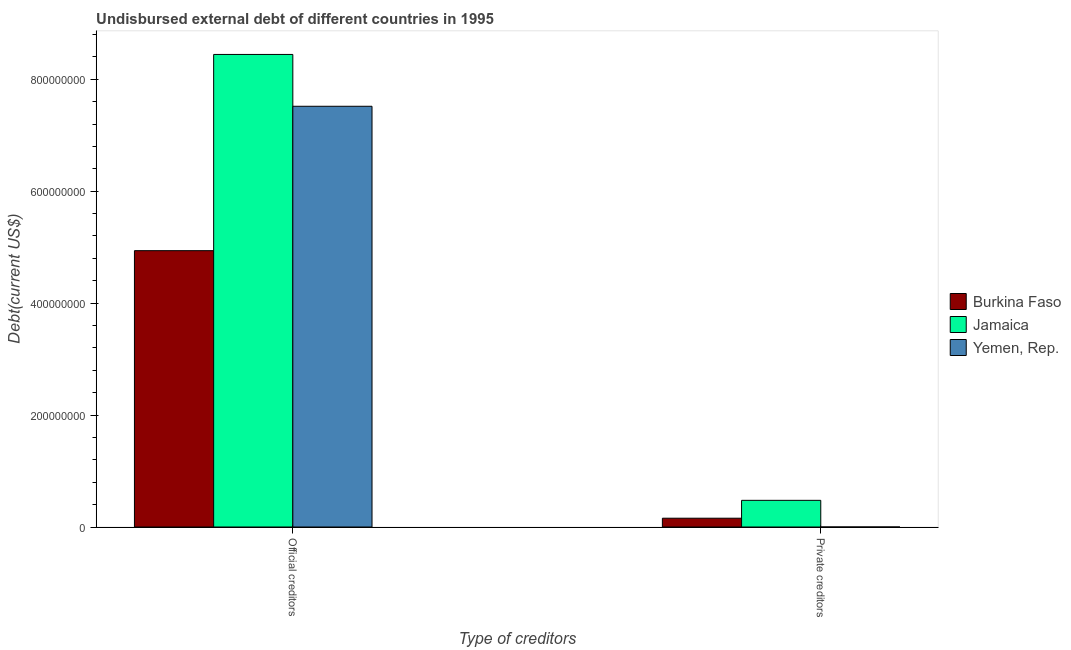Are the number of bars per tick equal to the number of legend labels?
Give a very brief answer. Yes. How many bars are there on the 2nd tick from the left?
Provide a short and direct response. 3. What is the label of the 1st group of bars from the left?
Your answer should be compact. Official creditors. What is the undisbursed external debt of private creditors in Burkina Faso?
Ensure brevity in your answer.  1.57e+07. Across all countries, what is the maximum undisbursed external debt of official creditors?
Your response must be concise. 8.44e+08. Across all countries, what is the minimum undisbursed external debt of official creditors?
Make the answer very short. 4.94e+08. In which country was the undisbursed external debt of private creditors maximum?
Your answer should be compact. Jamaica. In which country was the undisbursed external debt of private creditors minimum?
Your response must be concise. Yemen, Rep. What is the total undisbursed external debt of private creditors in the graph?
Offer a very short reply. 6.34e+07. What is the difference between the undisbursed external debt of official creditors in Yemen, Rep. and that in Burkina Faso?
Keep it short and to the point. 2.58e+08. What is the difference between the undisbursed external debt of private creditors in Jamaica and the undisbursed external debt of official creditors in Burkina Faso?
Make the answer very short. -4.46e+08. What is the average undisbursed external debt of official creditors per country?
Offer a terse response. 6.97e+08. What is the difference between the undisbursed external debt of official creditors and undisbursed external debt of private creditors in Burkina Faso?
Provide a succinct answer. 4.78e+08. What is the ratio of the undisbursed external debt of official creditors in Yemen, Rep. to that in Jamaica?
Ensure brevity in your answer.  0.89. In how many countries, is the undisbursed external debt of official creditors greater than the average undisbursed external debt of official creditors taken over all countries?
Provide a short and direct response. 2. What does the 1st bar from the left in Official creditors represents?
Ensure brevity in your answer.  Burkina Faso. What does the 2nd bar from the right in Private creditors represents?
Offer a very short reply. Jamaica. Are the values on the major ticks of Y-axis written in scientific E-notation?
Provide a succinct answer. No. Does the graph contain any zero values?
Your answer should be very brief. No. What is the title of the graph?
Your answer should be compact. Undisbursed external debt of different countries in 1995. What is the label or title of the X-axis?
Ensure brevity in your answer.  Type of creditors. What is the label or title of the Y-axis?
Your answer should be very brief. Debt(current US$). What is the Debt(current US$) of Burkina Faso in Official creditors?
Offer a very short reply. 4.94e+08. What is the Debt(current US$) of Jamaica in Official creditors?
Offer a very short reply. 8.44e+08. What is the Debt(current US$) in Yemen, Rep. in Official creditors?
Your response must be concise. 7.52e+08. What is the Debt(current US$) in Burkina Faso in Private creditors?
Keep it short and to the point. 1.57e+07. What is the Debt(current US$) of Jamaica in Private creditors?
Offer a very short reply. 4.77e+07. Across all Type of creditors, what is the maximum Debt(current US$) in Burkina Faso?
Offer a terse response. 4.94e+08. Across all Type of creditors, what is the maximum Debt(current US$) in Jamaica?
Your response must be concise. 8.44e+08. Across all Type of creditors, what is the maximum Debt(current US$) in Yemen, Rep.?
Your response must be concise. 7.52e+08. Across all Type of creditors, what is the minimum Debt(current US$) in Burkina Faso?
Ensure brevity in your answer.  1.57e+07. Across all Type of creditors, what is the minimum Debt(current US$) in Jamaica?
Offer a terse response. 4.77e+07. What is the total Debt(current US$) of Burkina Faso in the graph?
Give a very brief answer. 5.09e+08. What is the total Debt(current US$) of Jamaica in the graph?
Keep it short and to the point. 8.92e+08. What is the total Debt(current US$) of Yemen, Rep. in the graph?
Keep it short and to the point. 7.52e+08. What is the difference between the Debt(current US$) of Burkina Faso in Official creditors and that in Private creditors?
Your answer should be very brief. 4.78e+08. What is the difference between the Debt(current US$) in Jamaica in Official creditors and that in Private creditors?
Your answer should be very brief. 7.97e+08. What is the difference between the Debt(current US$) of Yemen, Rep. in Official creditors and that in Private creditors?
Your answer should be compact. 7.52e+08. What is the difference between the Debt(current US$) in Burkina Faso in Official creditors and the Debt(current US$) in Jamaica in Private creditors?
Offer a terse response. 4.46e+08. What is the difference between the Debt(current US$) of Burkina Faso in Official creditors and the Debt(current US$) of Yemen, Rep. in Private creditors?
Your answer should be very brief. 4.94e+08. What is the difference between the Debt(current US$) of Jamaica in Official creditors and the Debt(current US$) of Yemen, Rep. in Private creditors?
Your answer should be compact. 8.44e+08. What is the average Debt(current US$) of Burkina Faso per Type of creditors?
Offer a terse response. 2.55e+08. What is the average Debt(current US$) of Jamaica per Type of creditors?
Make the answer very short. 4.46e+08. What is the average Debt(current US$) in Yemen, Rep. per Type of creditors?
Your answer should be very brief. 3.76e+08. What is the difference between the Debt(current US$) of Burkina Faso and Debt(current US$) of Jamaica in Official creditors?
Provide a succinct answer. -3.51e+08. What is the difference between the Debt(current US$) in Burkina Faso and Debt(current US$) in Yemen, Rep. in Official creditors?
Make the answer very short. -2.58e+08. What is the difference between the Debt(current US$) of Jamaica and Debt(current US$) of Yemen, Rep. in Official creditors?
Offer a terse response. 9.26e+07. What is the difference between the Debt(current US$) in Burkina Faso and Debt(current US$) in Jamaica in Private creditors?
Your answer should be compact. -3.19e+07. What is the difference between the Debt(current US$) of Burkina Faso and Debt(current US$) of Yemen, Rep. in Private creditors?
Offer a very short reply. 1.57e+07. What is the difference between the Debt(current US$) in Jamaica and Debt(current US$) in Yemen, Rep. in Private creditors?
Offer a terse response. 4.77e+07. What is the ratio of the Debt(current US$) in Burkina Faso in Official creditors to that in Private creditors?
Make the answer very short. 31.38. What is the ratio of the Debt(current US$) in Jamaica in Official creditors to that in Private creditors?
Offer a very short reply. 17.71. What is the ratio of the Debt(current US$) in Yemen, Rep. in Official creditors to that in Private creditors?
Make the answer very short. 7.52e+05. What is the difference between the highest and the second highest Debt(current US$) in Burkina Faso?
Offer a terse response. 4.78e+08. What is the difference between the highest and the second highest Debt(current US$) in Jamaica?
Your response must be concise. 7.97e+08. What is the difference between the highest and the second highest Debt(current US$) in Yemen, Rep.?
Your answer should be very brief. 7.52e+08. What is the difference between the highest and the lowest Debt(current US$) of Burkina Faso?
Ensure brevity in your answer.  4.78e+08. What is the difference between the highest and the lowest Debt(current US$) in Jamaica?
Your answer should be compact. 7.97e+08. What is the difference between the highest and the lowest Debt(current US$) in Yemen, Rep.?
Keep it short and to the point. 7.52e+08. 